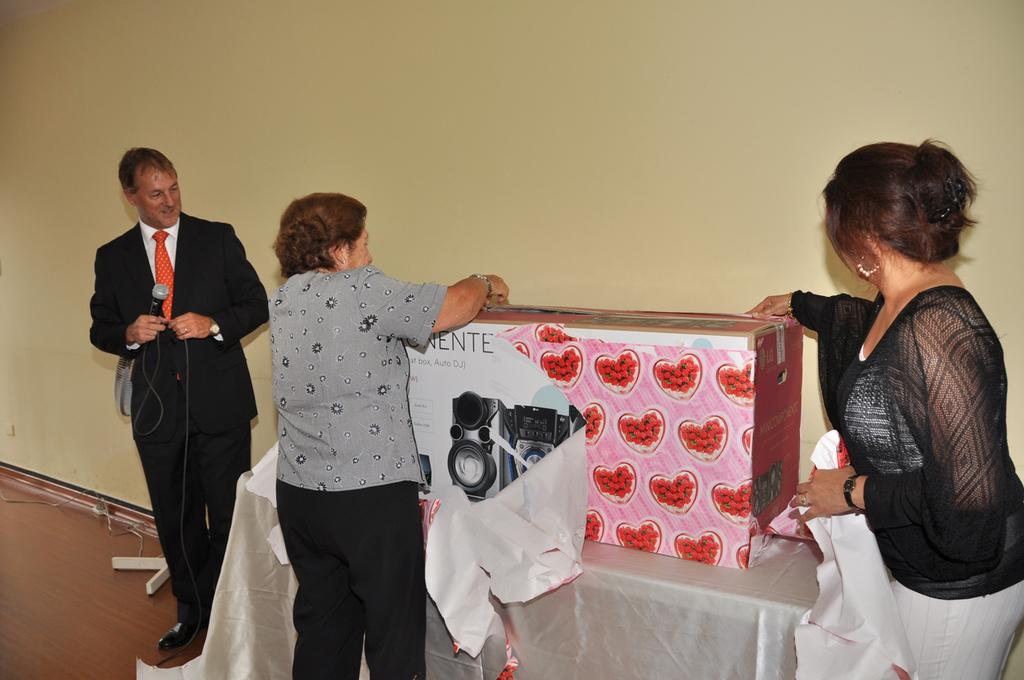How many people are present in the image? There are three persons standing in the image. What are two of the persons holding? Two persons are holding a box. What is the third person holding? One person is holding a microphone. What can be seen in the background of the image? There is a wall in the background of the image. What type of cheese is being used as a bead in the image? There is no cheese or bead present in the image. What is the value of the box being held by the two persons? The value of the box cannot be determined from the image, as it does not provide any information about the contents or worth of the box. 